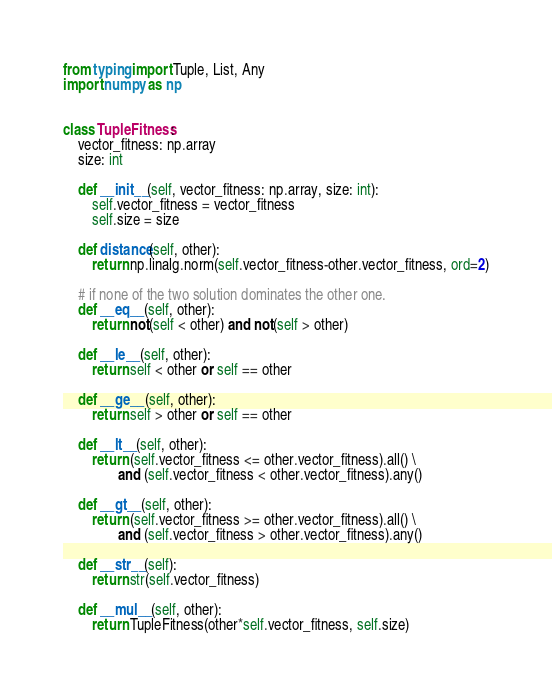<code> <loc_0><loc_0><loc_500><loc_500><_Python_>from typing import Tuple, List, Any
import numpy as np


class TupleFitness:
    vector_fitness: np.array
    size: int

    def __init__(self, vector_fitness: np.array, size: int):
        self.vector_fitness = vector_fitness
        self.size = size

    def distance(self, other):
        return np.linalg.norm(self.vector_fitness-other.vector_fitness, ord=2)

    # if none of the two solution dominates the other one.
    def __eq__(self, other):
        return not(self < other) and not(self > other)

    def __le__(self, other):
        return self < other or self == other

    def __ge__(self, other):
        return self > other or self == other

    def __lt__(self, other):
        return (self.vector_fitness <= other.vector_fitness).all() \
               and (self.vector_fitness < other.vector_fitness).any()

    def __gt__(self, other):
        return (self.vector_fitness >= other.vector_fitness).all() \
               and (self.vector_fitness > other.vector_fitness).any()

    def __str__(self):
        return str(self.vector_fitness)

    def __mul__(self, other):
        return TupleFitness(other*self.vector_fitness, self.size)





</code> 